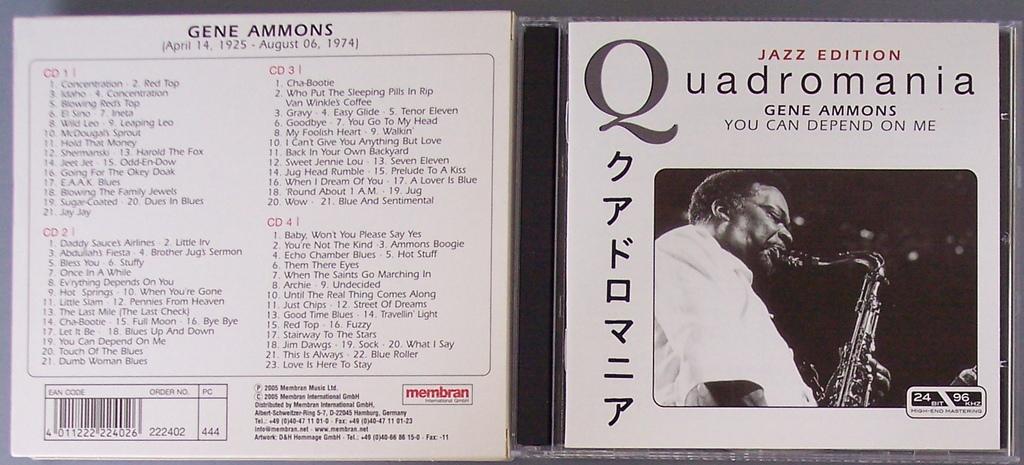What edition is this cd'?
Provide a succinct answer. Jazz. What is one of the years on the top part of the back of the case?
Offer a very short reply. 1925. 